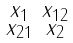<formula> <loc_0><loc_0><loc_500><loc_500>\begin{smallmatrix} x _ { 1 } & x _ { 1 2 } \\ x _ { 2 1 } & x _ { 2 } \end{smallmatrix}</formula> 